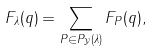Convert formula to latex. <formula><loc_0><loc_0><loc_500><loc_500>F _ { \lambda } ( q ) = \sum _ { P \in P _ { \mathcal { Y } } ( \lambda ) } F _ { P } ( q ) ,</formula> 